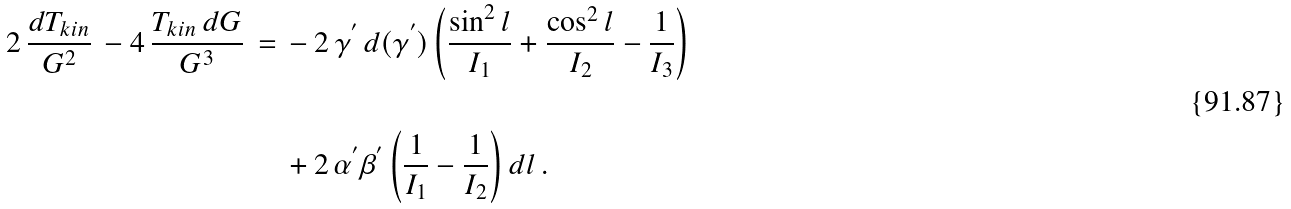Convert formula to latex. <formula><loc_0><loc_0><loc_500><loc_500>2 \, \frac { d T _ { k i n } } { G ^ { 2 } } \, - 4 \, \frac { T _ { k i n } \, d G } { G ^ { 3 } } \, = \, & - 2 \, { \gamma } ^ { ^ { \prime } } \, d ( { \gamma } ^ { ^ { \prime } } ) \left ( \frac { \sin ^ { 2 } l } { I _ { 1 } } + \frac { \cos ^ { 2 } l } { I _ { 2 } } - \frac { 1 } { I _ { 3 } } \right ) \\ \\ & + 2 \, { \alpha } ^ { ^ { \prime } } { \beta } ^ { ^ { \prime } } \left ( \frac { 1 } { I _ { 1 } } - \frac { 1 } { I _ { 2 } } \right ) d l \, .</formula> 